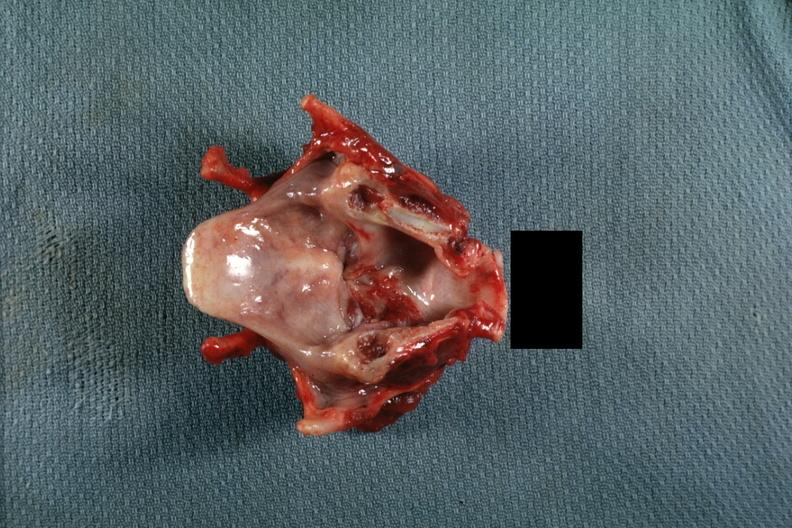where is this?
Answer the question using a single word or phrase. Oral 